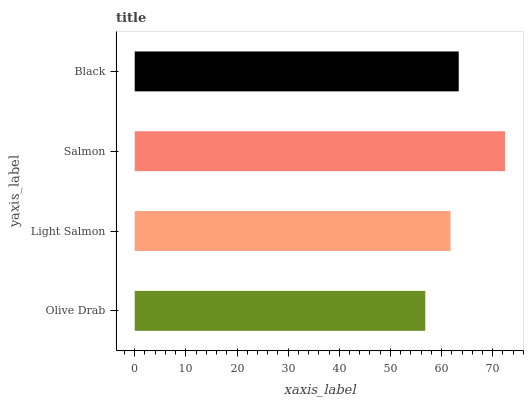Is Olive Drab the minimum?
Answer yes or no. Yes. Is Salmon the maximum?
Answer yes or no. Yes. Is Light Salmon the minimum?
Answer yes or no. No. Is Light Salmon the maximum?
Answer yes or no. No. Is Light Salmon greater than Olive Drab?
Answer yes or no. Yes. Is Olive Drab less than Light Salmon?
Answer yes or no. Yes. Is Olive Drab greater than Light Salmon?
Answer yes or no. No. Is Light Salmon less than Olive Drab?
Answer yes or no. No. Is Black the high median?
Answer yes or no. Yes. Is Light Salmon the low median?
Answer yes or no. Yes. Is Olive Drab the high median?
Answer yes or no. No. Is Olive Drab the low median?
Answer yes or no. No. 